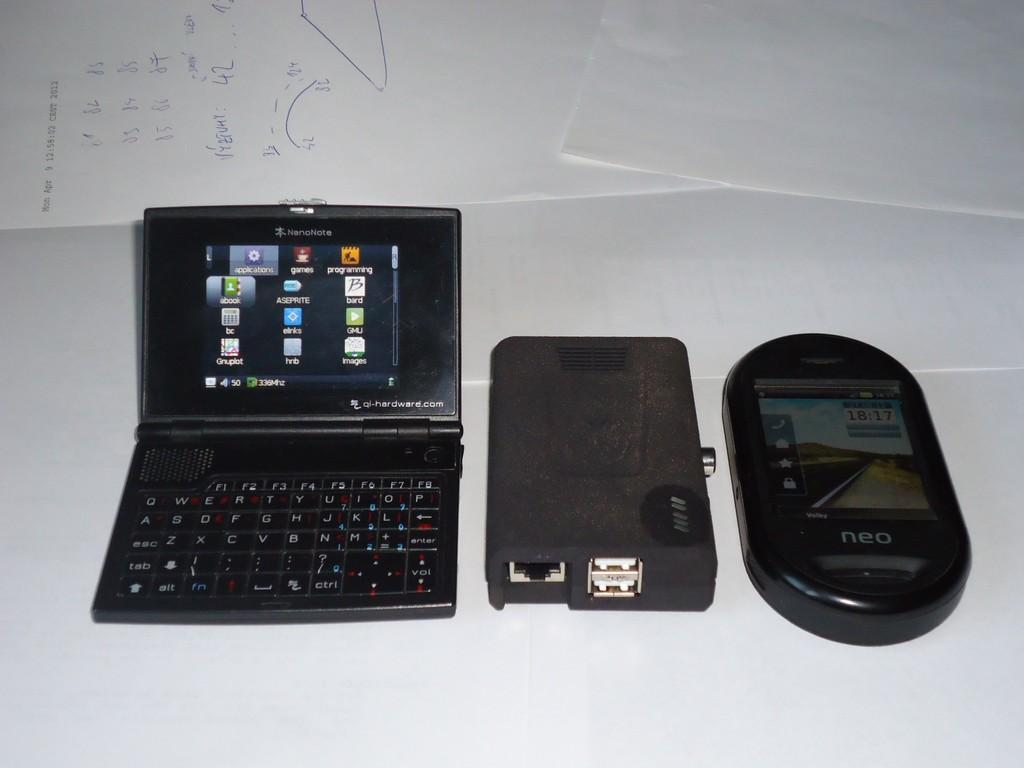Provide a one-sentence caption for the provided image. A Nanonote device sits next to other components on a white surface. 